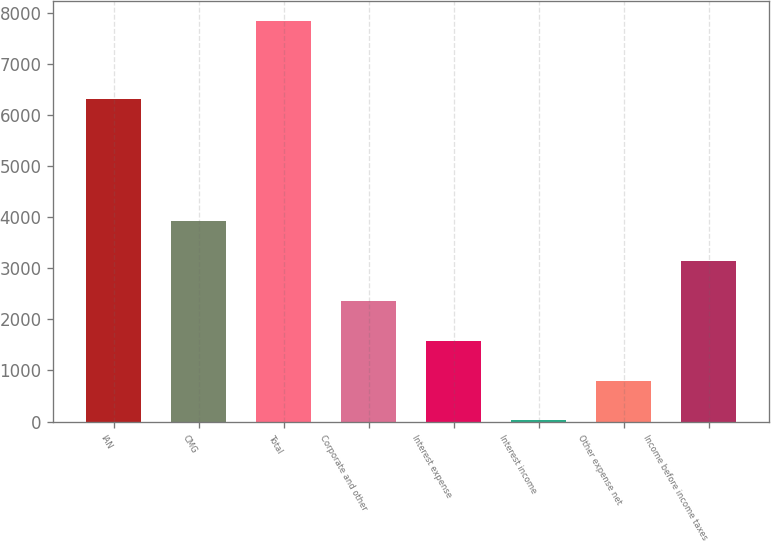Convert chart. <chart><loc_0><loc_0><loc_500><loc_500><bar_chart><fcel>IAN<fcel>CMG<fcel>Total<fcel>Corporate and other<fcel>Interest expense<fcel>Interest income<fcel>Other expense net<fcel>Income before income taxes<nl><fcel>6319.4<fcel>3933.35<fcel>7846.6<fcel>2368.05<fcel>1585.4<fcel>20.1<fcel>802.75<fcel>3150.7<nl></chart> 